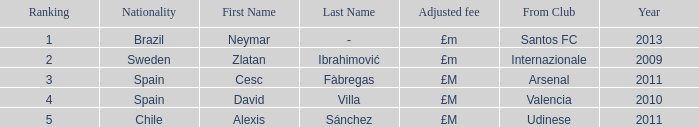What is the latest year a player originated from valencia? 2010.0. 